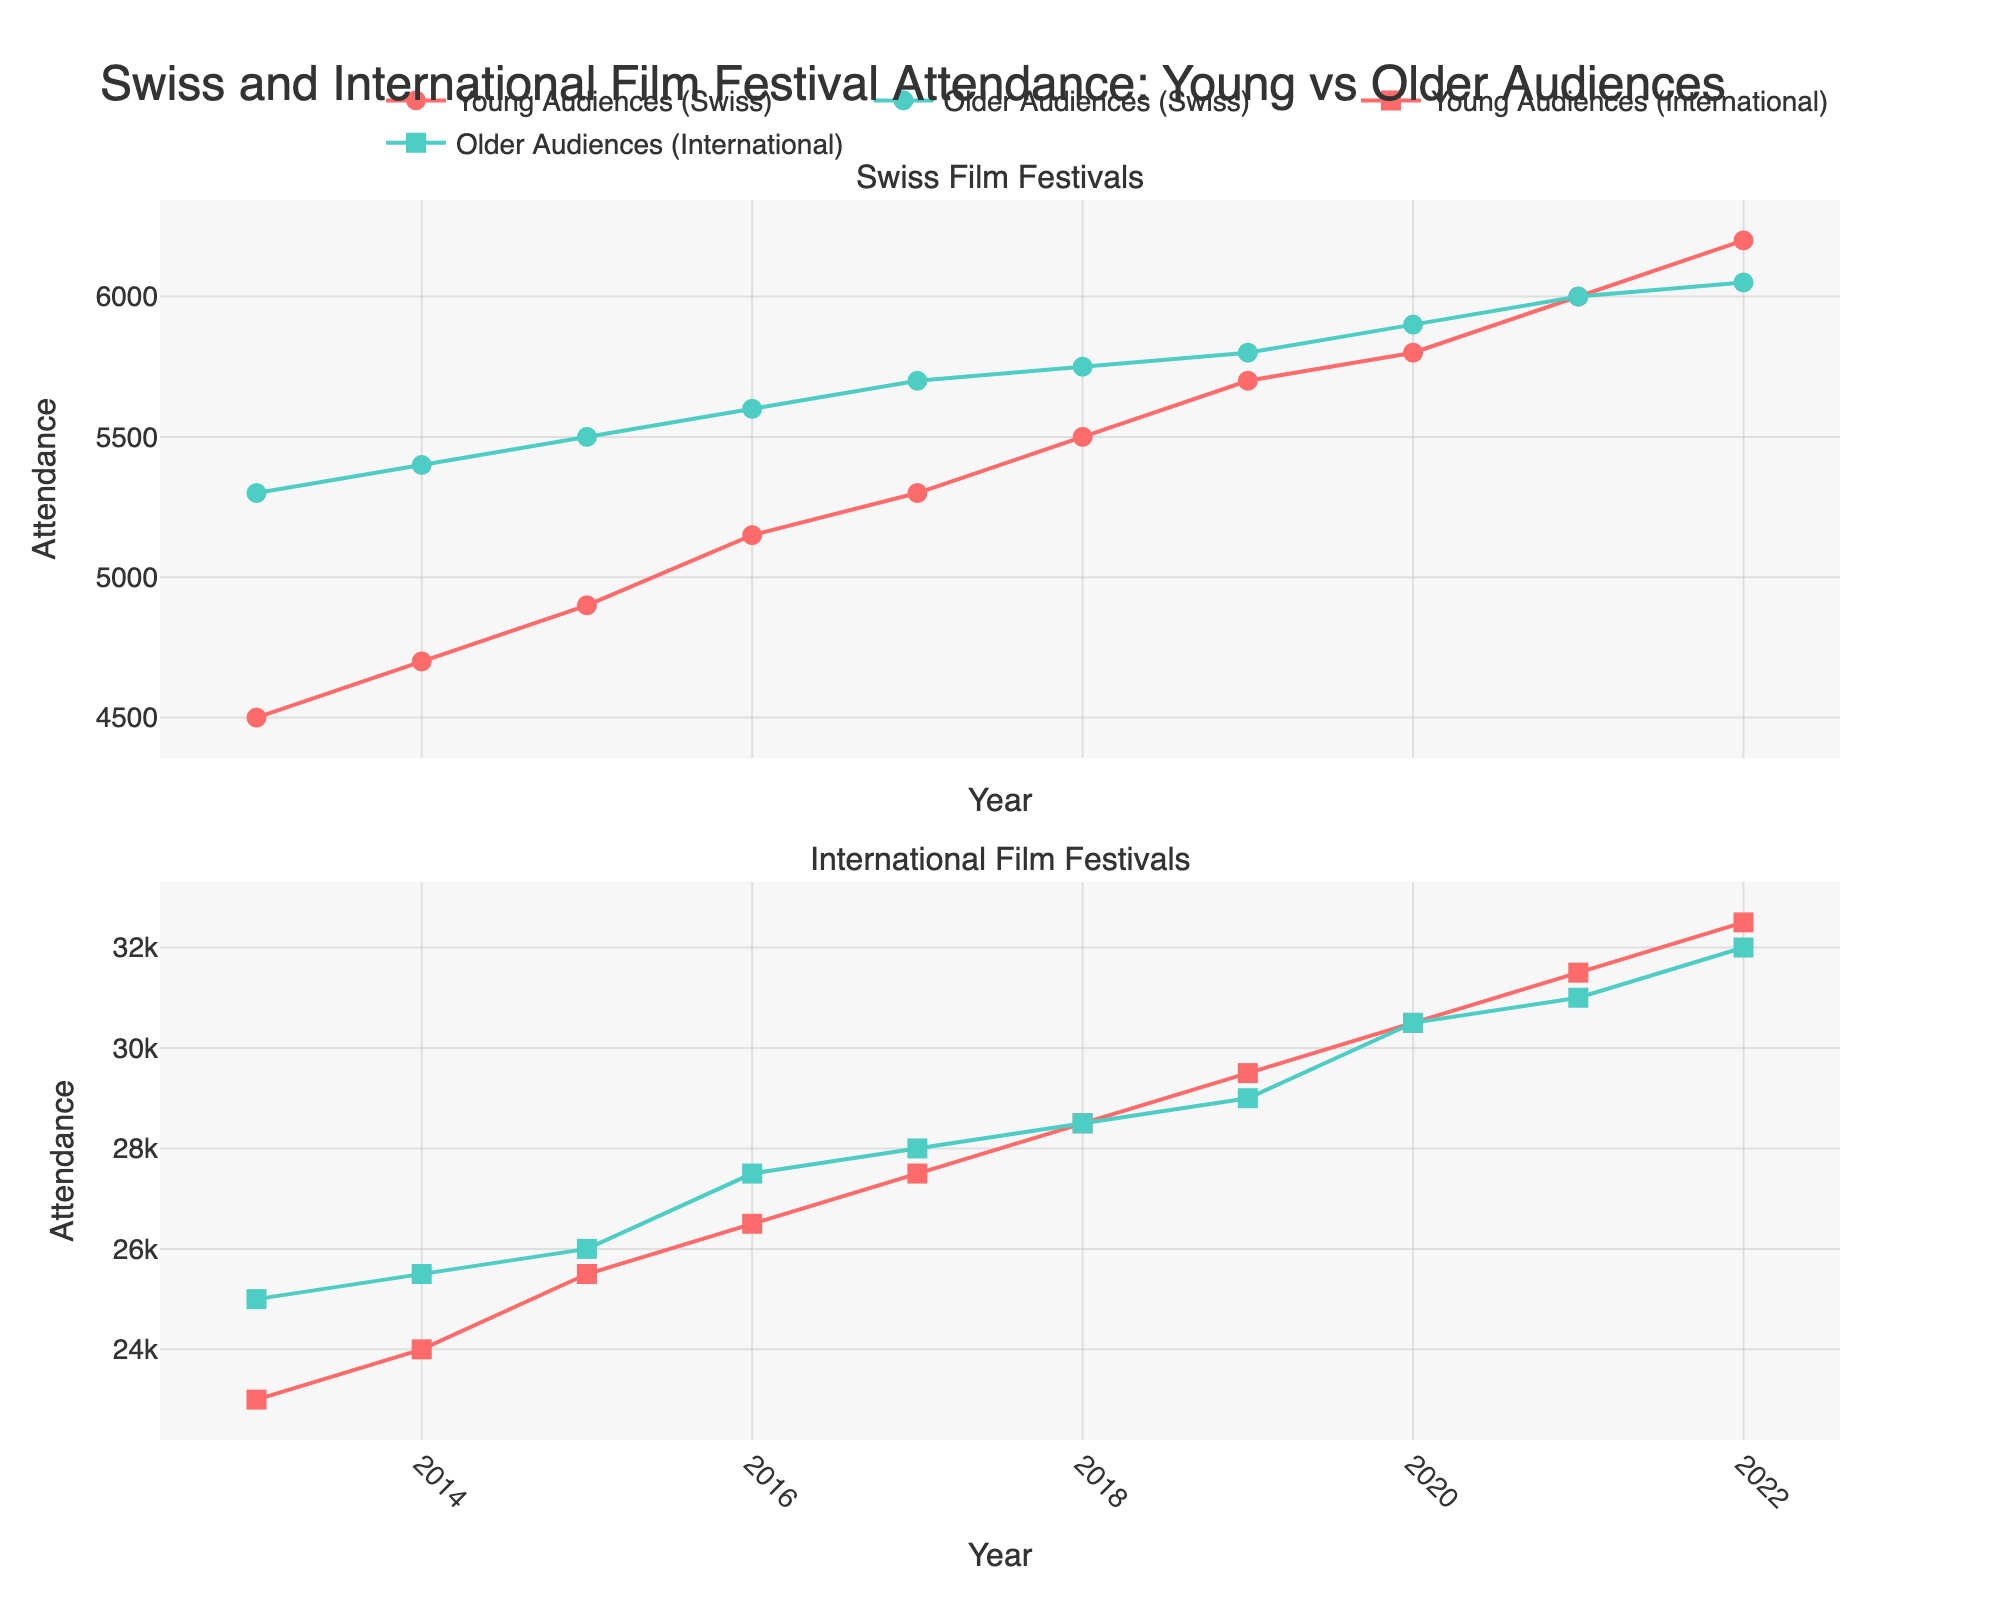How many different audience categories are compared in the figure? The figure compares two categories of audiences, young and older, for both Swiss and International film festivals.
Answer: Four Which year shows the highest attendance for Young Audiences at Swiss film festivals? Looking at the trend lines for Swiss Young Audiences, the attendance peaks in 2022.
Answer: 2022 How does the attendance of Older Audiences at International film festivals change from 2013 to 2022? International Older Audiences start at 25,000 in 2013 and gradually increase to 32,000 in 2022.
Answer: Increased In which year do Swiss Older Audiences and Swiss Young Audiences have the same attendance? Both Swiss Older Audiences and Swiss Young Audiences have an attendance of 6,000 in 2021.
Answer: 2021 What is the difference in attendance between Young Audiences and Older Audiences at International film festivals in 2019? In 2019, International Young Audiences had 29,500 attendees, while Older Audiences had 29,000. The difference is 29,500 - 29,000 = 500.
Answer: 500 Which group shows the most consistent increase over the years? By observing the trend, Swiss Young Audiences show a consistent increase from 2013 to 2022.
Answer: Swiss Young Audiences Compare the attendance of Swiss Young Audiences in 2016 with International Young Audiences in 2016. Which group had higher attendance? The Swiss Young Audiences had 5,150 attendees, whereas International Young Audiences had 26,500 attendees. Thus, the International Young Audiences had higher attendance.
Answer: International Young Audiences Between which years does the attendance of Older Audiences at International film festivals see the most significant increase? The significant increase in attendance for International Older Audiences happens between 2015 and 2016, from 26,000 to 27,500.
Answer: 2015 to 2016 Which group had the smallest attendance increase over the entire period? Swiss Older Audiences started at 5,300 in 2013 and reached 6,050 in 2022, showing the smallest increase among the groups.
Answer: Swiss Older Audiences Calculate the average attendance of Swiss Older Audiences over the decade. Sum the attendance values from 2013 to 2022: 5,300 + 5,400 + 5,500 + 5,600 + 5,700 + 5,750 + 5,800 + 5,900 + 6,000 + 6,050 = 56,000. The average is 56,000 / 10 = 5,600.
Answer: 5,600 